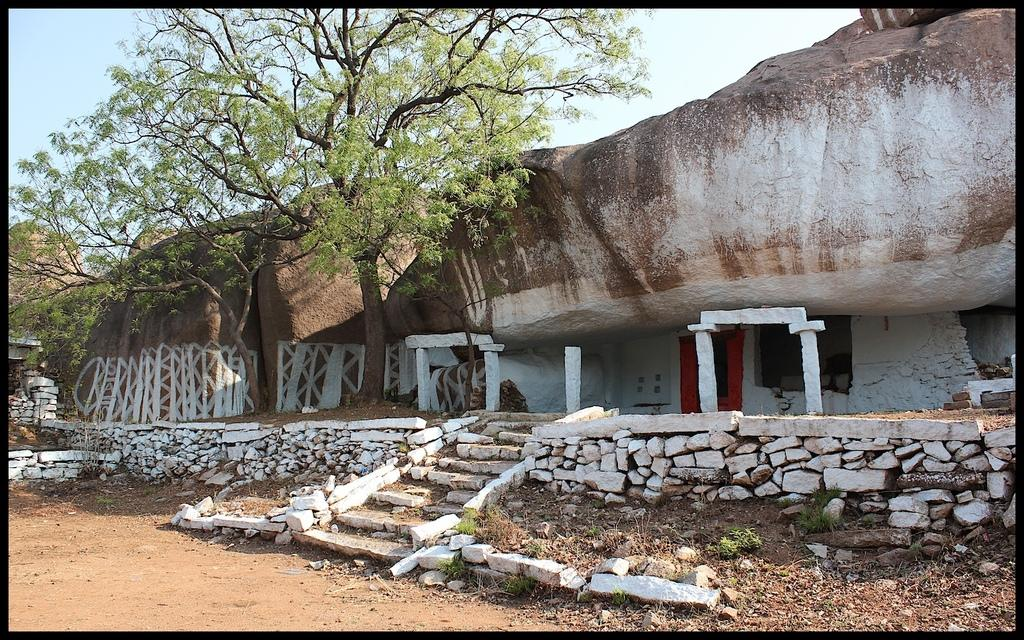What type of structure can be seen in the image? There are stairs in the image. What type of natural elements are present in the image? There are stones, rocks, a tree, and sand visible in the image. What is visible in the background of the image? The sky is visible in the image. Can you hear any music playing near the lake in the image? There is no lake present in the image, and therefore no music can be heard. Is there a police officer visible in the image? There is no police officer present in the image. 